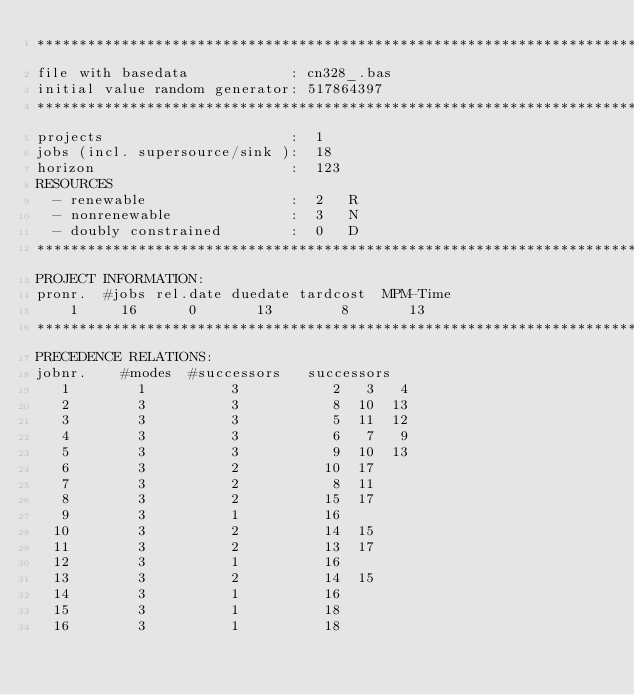Convert code to text. <code><loc_0><loc_0><loc_500><loc_500><_ObjectiveC_>************************************************************************
file with basedata            : cn328_.bas
initial value random generator: 517864397
************************************************************************
projects                      :  1
jobs (incl. supersource/sink ):  18
horizon                       :  123
RESOURCES
  - renewable                 :  2   R
  - nonrenewable              :  3   N
  - doubly constrained        :  0   D
************************************************************************
PROJECT INFORMATION:
pronr.  #jobs rel.date duedate tardcost  MPM-Time
    1     16      0       13        8       13
************************************************************************
PRECEDENCE RELATIONS:
jobnr.    #modes  #successors   successors
   1        1          3           2   3   4
   2        3          3           8  10  13
   3        3          3           5  11  12
   4        3          3           6   7   9
   5        3          3           9  10  13
   6        3          2          10  17
   7        3          2           8  11
   8        3          2          15  17
   9        3          1          16
  10        3          2          14  15
  11        3          2          13  17
  12        3          1          16
  13        3          2          14  15
  14        3          1          16
  15        3          1          18
  16        3          1          18</code> 